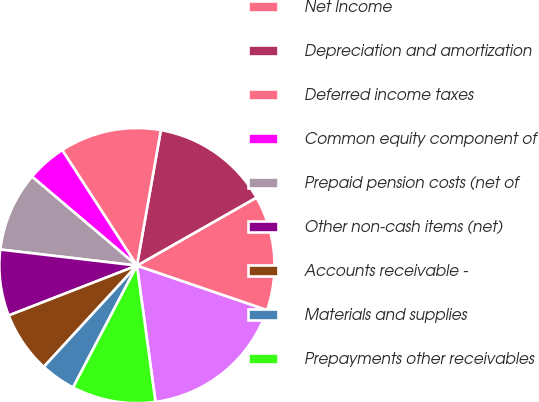Convert chart to OTSL. <chart><loc_0><loc_0><loc_500><loc_500><pie_chart><fcel>(Millions of Dollars)<fcel>Net Income<fcel>Depreciation and amortization<fcel>Deferred income taxes<fcel>Common equity component of<fcel>Prepaid pension costs (net of<fcel>Other non-cash items (net)<fcel>Accounts receivable -<fcel>Materials and supplies<fcel>Prepayments other receivables<nl><fcel>17.61%<fcel>13.47%<fcel>13.99%<fcel>11.92%<fcel>4.67%<fcel>9.33%<fcel>7.77%<fcel>7.26%<fcel>4.15%<fcel>9.84%<nl></chart> 